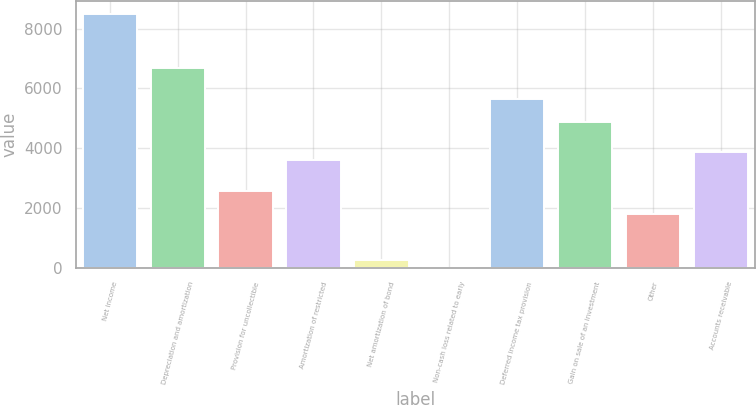<chart> <loc_0><loc_0><loc_500><loc_500><bar_chart><fcel>Net income<fcel>Depreciation and amortization<fcel>Provision for uncollectible<fcel>Amortization of restricted<fcel>Net amortization of bond<fcel>Non-cash loss related to early<fcel>Deferred income tax provision<fcel>Gain on sale of an investment<fcel>Other<fcel>Accounts receivable<nl><fcel>8493.63<fcel>6692.25<fcel>2574.81<fcel>3604.17<fcel>258.75<fcel>1.41<fcel>5662.89<fcel>4890.87<fcel>1802.79<fcel>3861.51<nl></chart> 